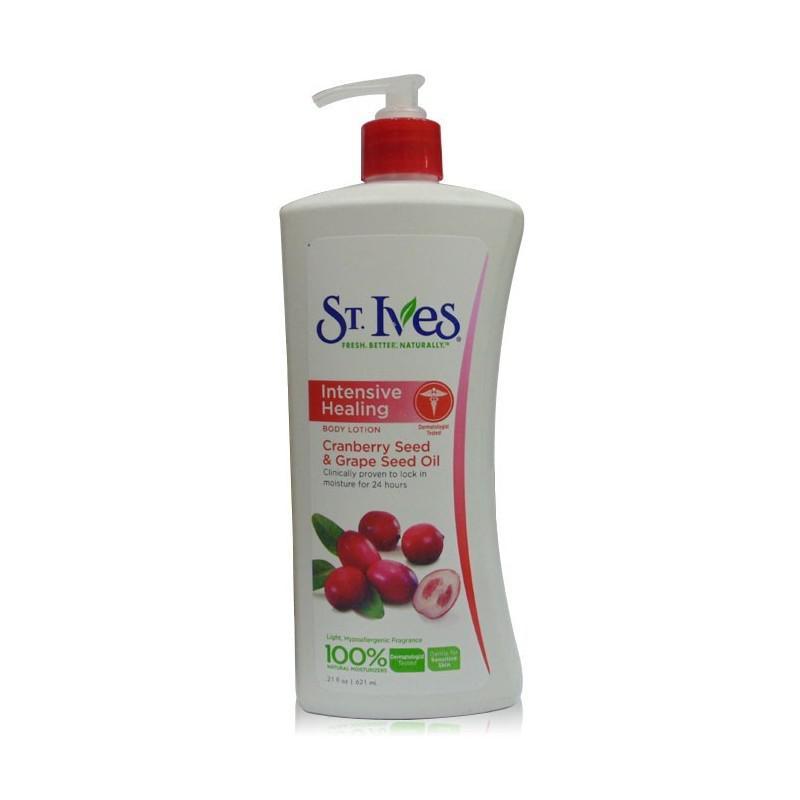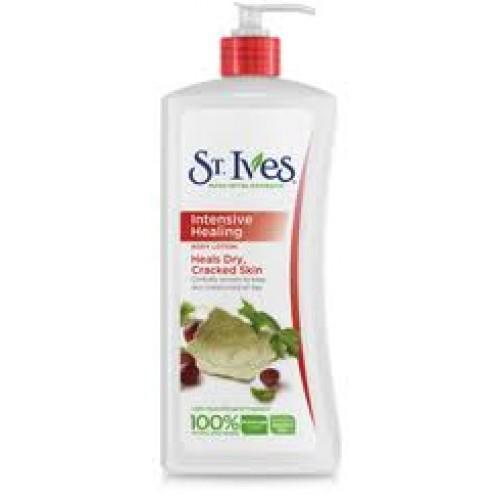The first image is the image on the left, the second image is the image on the right. For the images displayed, is the sentence "Each image has one bottle of lotion with a pump top, both the same brand, but with different labels." factually correct? Answer yes or no. Yes. The first image is the image on the left, the second image is the image on the right. Considering the images on both sides, is "One image shows exactly one pump-top product with the nozzle facing right, and the other image shows exactly one pump-top product with the nozzle facing left." valid? Answer yes or no. Yes. 